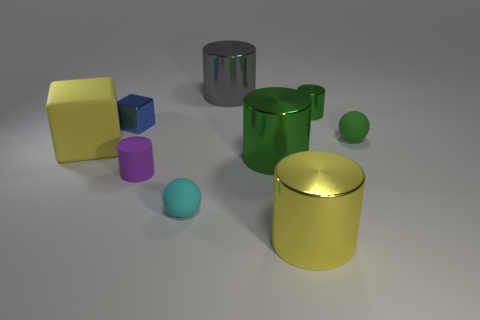Is there a thing that has the same material as the large gray cylinder?
Offer a terse response. Yes. There is a yellow thing that is the same size as the yellow shiny cylinder; what is its material?
Provide a succinct answer. Rubber. There is a big object that is in front of the rubber ball to the left of the large thing on the right side of the big green thing; what is its color?
Provide a short and direct response. Yellow. There is a shiny object to the right of the large yellow cylinder; is it the same shape as the large yellow thing behind the purple rubber object?
Your answer should be very brief. No. What number of brown matte balls are there?
Ensure brevity in your answer.  0. What color is the shiny cylinder that is the same size as the cyan sphere?
Offer a terse response. Green. Are the cylinder to the left of the gray thing and the small thing to the left of the small matte cylinder made of the same material?
Offer a terse response. No. What size is the green rubber ball behind the tiny rubber ball on the left side of the small green sphere?
Your response must be concise. Small. What is the big yellow object to the right of the blue block made of?
Keep it short and to the point. Metal. What number of objects are metal objects right of the gray shiny cylinder or tiny matte spheres in front of the gray cylinder?
Make the answer very short. 5. 